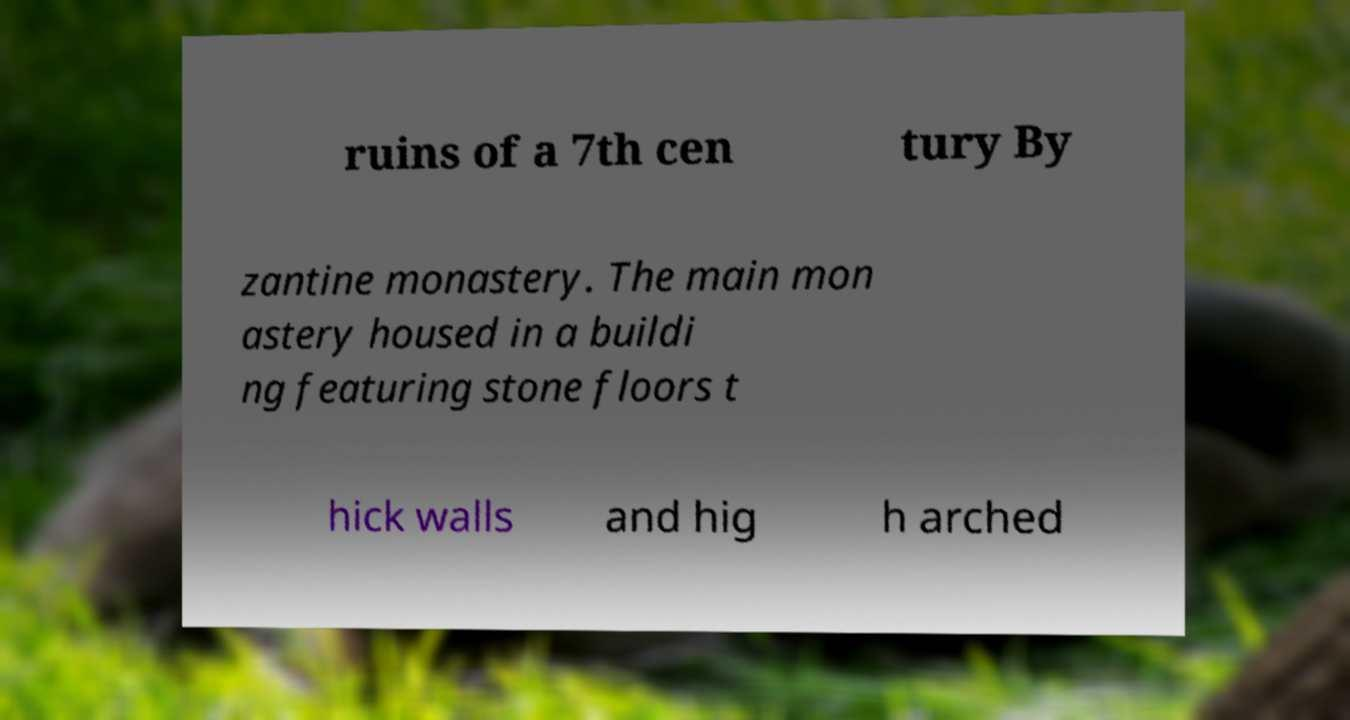Could you assist in decoding the text presented in this image and type it out clearly? ruins of a 7th cen tury By zantine monastery. The main mon astery housed in a buildi ng featuring stone floors t hick walls and hig h arched 